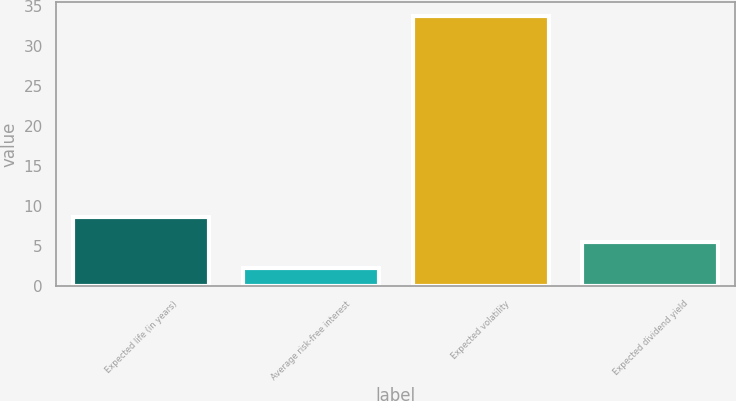Convert chart. <chart><loc_0><loc_0><loc_500><loc_500><bar_chart><fcel>Expected life (in years)<fcel>Average risk-free interest<fcel>Expected volatility<fcel>Expected dividend yield<nl><fcel>8.58<fcel>2.3<fcel>33.7<fcel>5.44<nl></chart> 